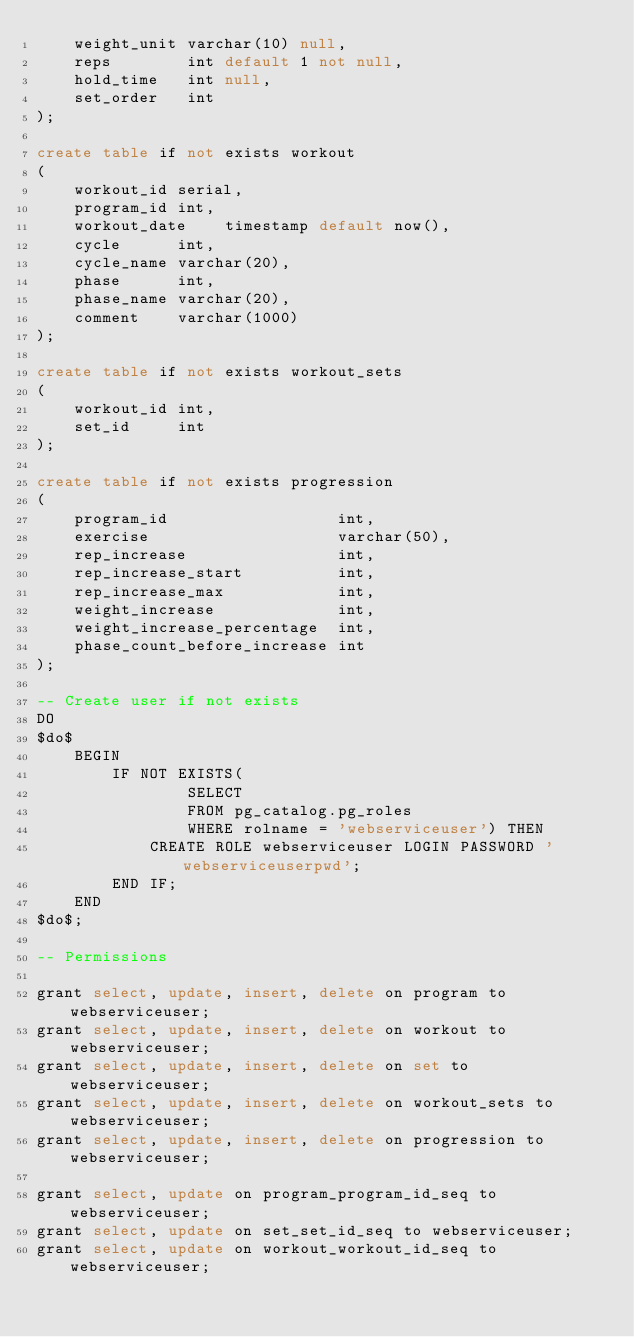<code> <loc_0><loc_0><loc_500><loc_500><_SQL_>    weight_unit varchar(10) null,
    reps        int default 1 not null,
    hold_time   int null,
    set_order   int
);

create table if not exists workout
(
    workout_id serial,
    program_id int,
    workout_date    timestamp default now(),
    cycle      int,
    cycle_name varchar(20),
    phase      int,
    phase_name varchar(20),
    comment    varchar(1000)
);

create table if not exists workout_sets
(
    workout_id int,
    set_id     int
);

create table if not exists progression
(
    program_id                  int,
    exercise                    varchar(50),
    rep_increase                int,
    rep_increase_start          int,
    rep_increase_max            int,
    weight_increase             int,
    weight_increase_percentage  int,
    phase_count_before_increase int
);

-- Create user if not exists
DO
$do$
    BEGIN
        IF NOT EXISTS(
                SELECT
                FROM pg_catalog.pg_roles
                WHERE rolname = 'webserviceuser') THEN
            CREATE ROLE webserviceuser LOGIN PASSWORD 'webserviceuserpwd';
        END IF;
    END
$do$;

-- Permissions

grant select, update, insert, delete on program to webserviceuser;
grant select, update, insert, delete on workout to webserviceuser;
grant select, update, insert, delete on set to webserviceuser;
grant select, update, insert, delete on workout_sets to webserviceuser;
grant select, update, insert, delete on progression to webserviceuser;

grant select, update on program_program_id_seq to webserviceuser;
grant select, update on set_set_id_seq to webserviceuser;
grant select, update on workout_workout_id_seq to webserviceuser;

</code> 